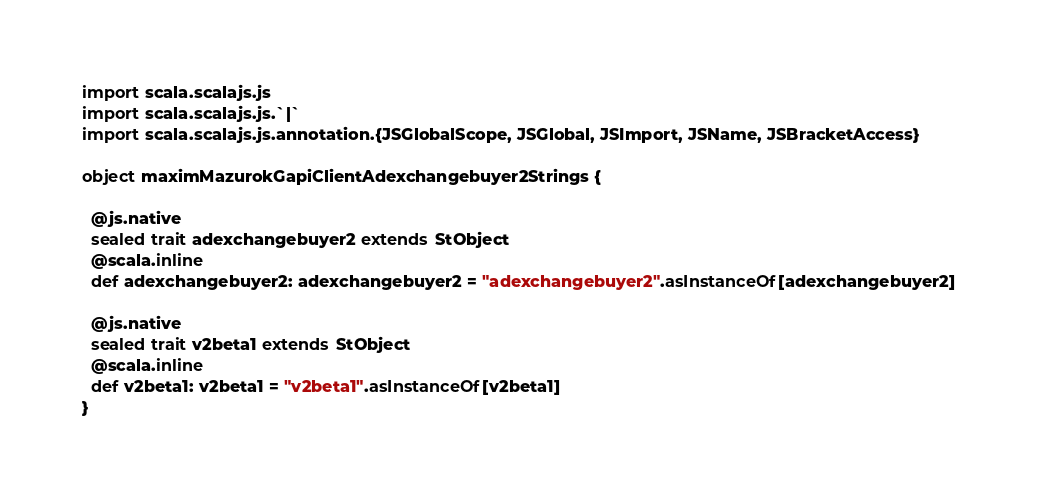<code> <loc_0><loc_0><loc_500><loc_500><_Scala_>import scala.scalajs.js
import scala.scalajs.js.`|`
import scala.scalajs.js.annotation.{JSGlobalScope, JSGlobal, JSImport, JSName, JSBracketAccess}

object maximMazurokGapiClientAdexchangebuyer2Strings {
  
  @js.native
  sealed trait adexchangebuyer2 extends StObject
  @scala.inline
  def adexchangebuyer2: adexchangebuyer2 = "adexchangebuyer2".asInstanceOf[adexchangebuyer2]
  
  @js.native
  sealed trait v2beta1 extends StObject
  @scala.inline
  def v2beta1: v2beta1 = "v2beta1".asInstanceOf[v2beta1]
}
</code> 